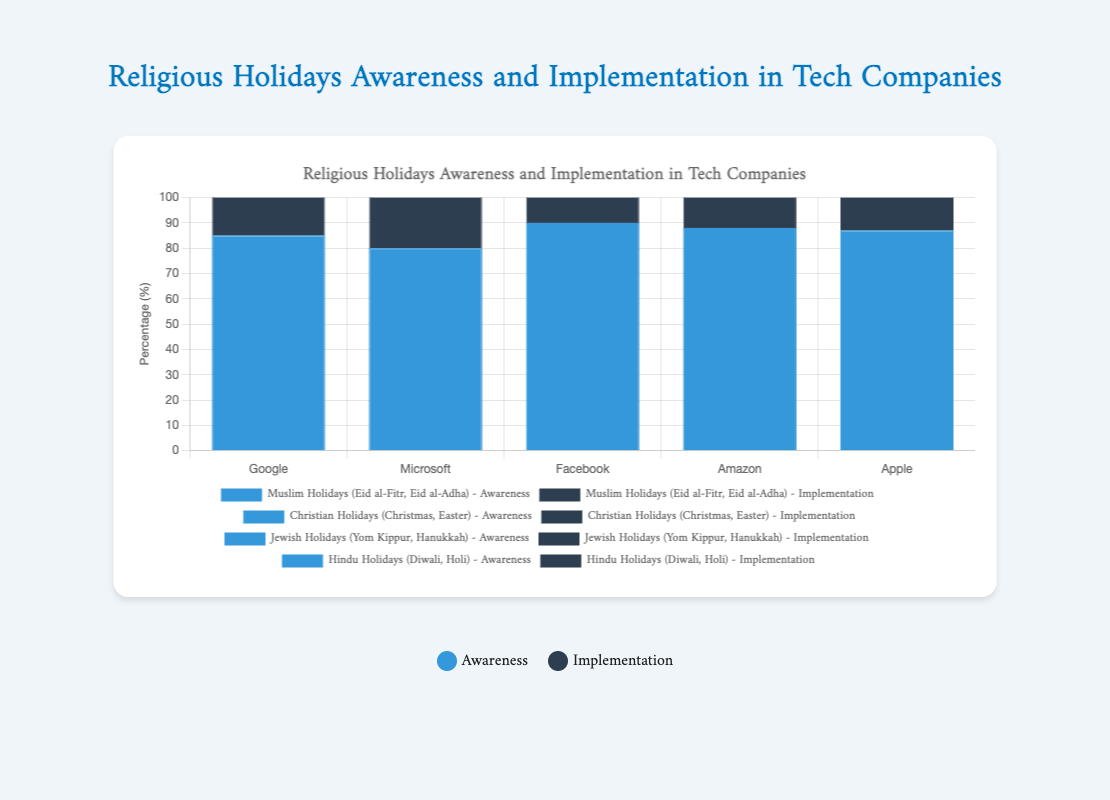Which company has the highest awareness of Muslim holidays? By looking at the height of the bars representing "Awareness" for Muslim holidays across different companies, we see that Facebook has the highest value at 90.
Answer: Facebook Which company shows the greatest difference between awareness and implementation for Hindu holidays? To find this, we need to calculate the difference between the "Awareness" and "Implementation" values for Hindu holidays for each company. Google: 75-60=15, Microsoft: 65-50=15, Facebook: 78-65=13, Amazon: 70-55=15, Apple: 72-58=14. All three companies, Google, Microsoft, and Amazon, show the greatest difference of 15.
Answer: Google, Microsoft, Amazon For Christian holidays, what's the average implementation percentage across all companies? We calculate the mean of the "Implementation" values for Christian holidays. Google: 90, Microsoft: 85, Facebook: 95, Amazon: 90, Apple: 92. Adding these gives 452. Dividing by 5 gives 452/5 = 90.4.
Answer: 90.4 Compare the awareness of Jewish holidays between Google and Microsoft. Which company has a higher awareness? Google's awareness for Jewish holidays is 80, and Microsoft's is 70. Comparing these two values, Google has a higher awareness.
Answer: Google Which religious holiday category has the lowest implementation rate across any company? Among all categories and companies, we observe that Hindu holidays at Microsoft have the lowest implementation rate with a value of 50.
Answer: Hindu holidays at Microsoft What is the combined implementation percentage for Muslim holidays at Google and Facebook? Google has an implementation percentage of 70, and Facebook has 75. Adding these values gives 70 + 75 = 145.
Answer: 145 Which religious holiday category has the smallest difference between awareness and implementation for Amazon? For Amazon, the differences are: Muslim: 88-72=16, Christian: 97-90=7, Jewish: 82-68=14, Hindu: 70-55=15. The smallest difference is for Christian holidays, which is 7.
Answer: Christian holidays For Muslim holidays, what is the difference in implementation between Facebook and Apple? Facebook's implementation value is 75, and Apple's is 73. The difference is 75 - 73 = 2.
Answer: 2 How does Facebook's awareness for Hindu holidays compare to Google's? Facebook's awareness rate for Hindu holidays is 78, while Google's is 75. Facebook has a higher awareness.
Answer: Facebook 